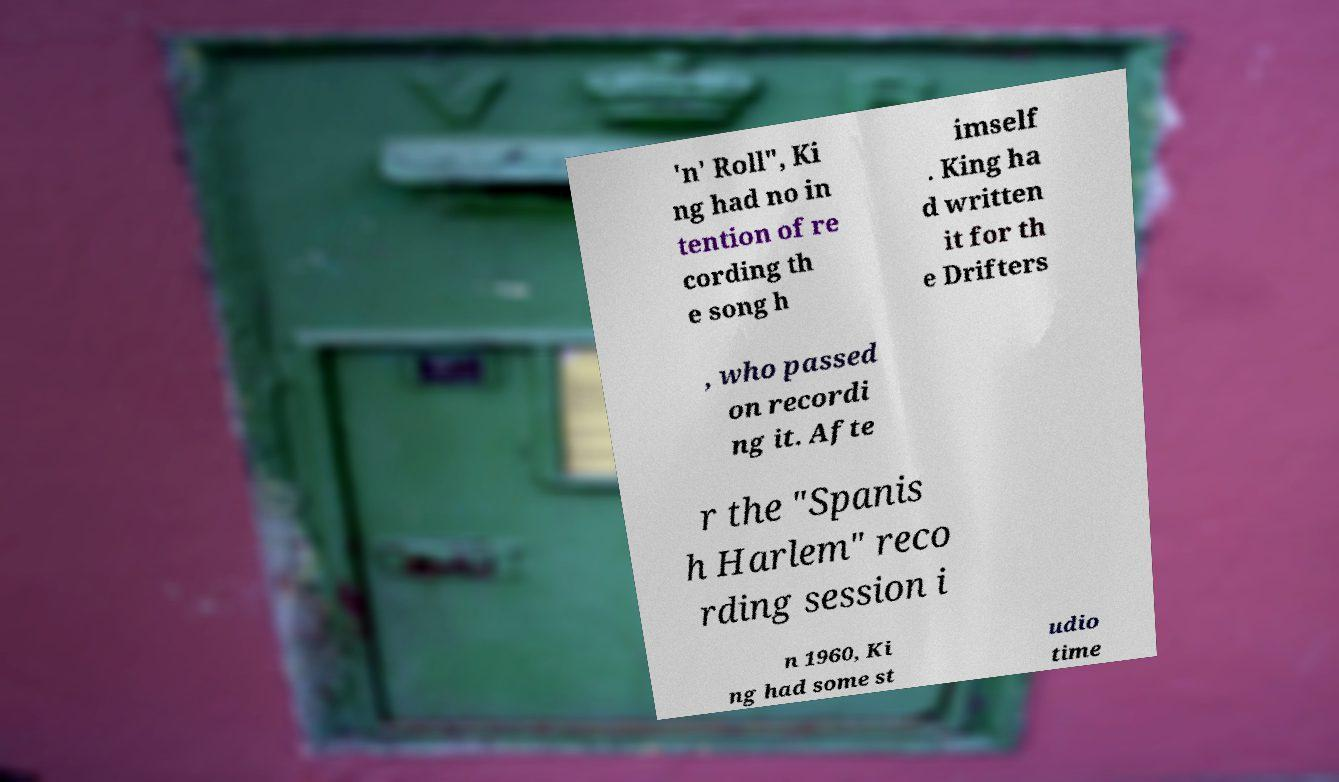Could you extract and type out the text from this image? 'n' Roll", Ki ng had no in tention of re cording th e song h imself . King ha d written it for th e Drifters , who passed on recordi ng it. Afte r the "Spanis h Harlem" reco rding session i n 1960, Ki ng had some st udio time 